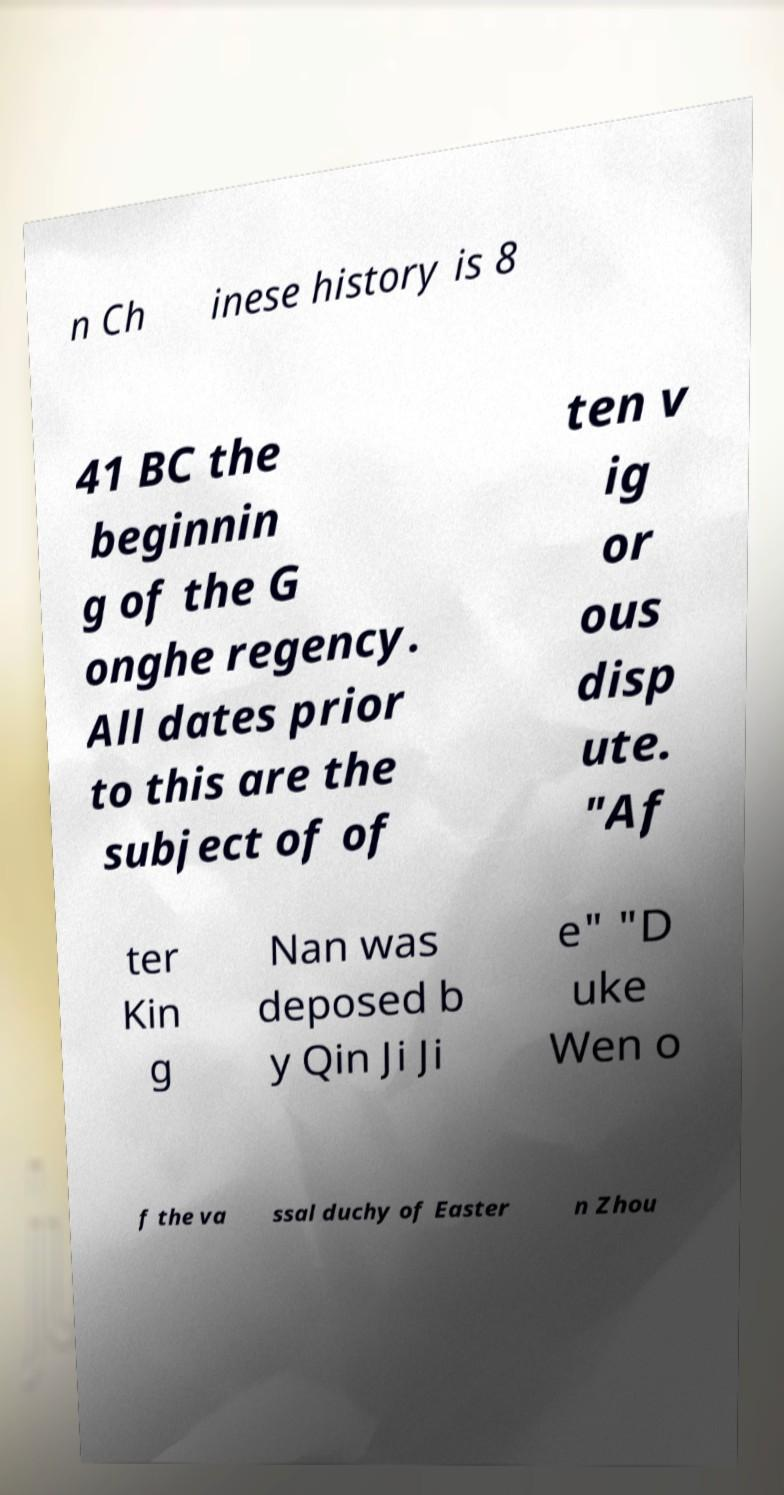What messages or text are displayed in this image? I need them in a readable, typed format. n Ch inese history is 8 41 BC the beginnin g of the G onghe regency. All dates prior to this are the subject of of ten v ig or ous disp ute. "Af ter Kin g Nan was deposed b y Qin Ji Ji e" "D uke Wen o f the va ssal duchy of Easter n Zhou 